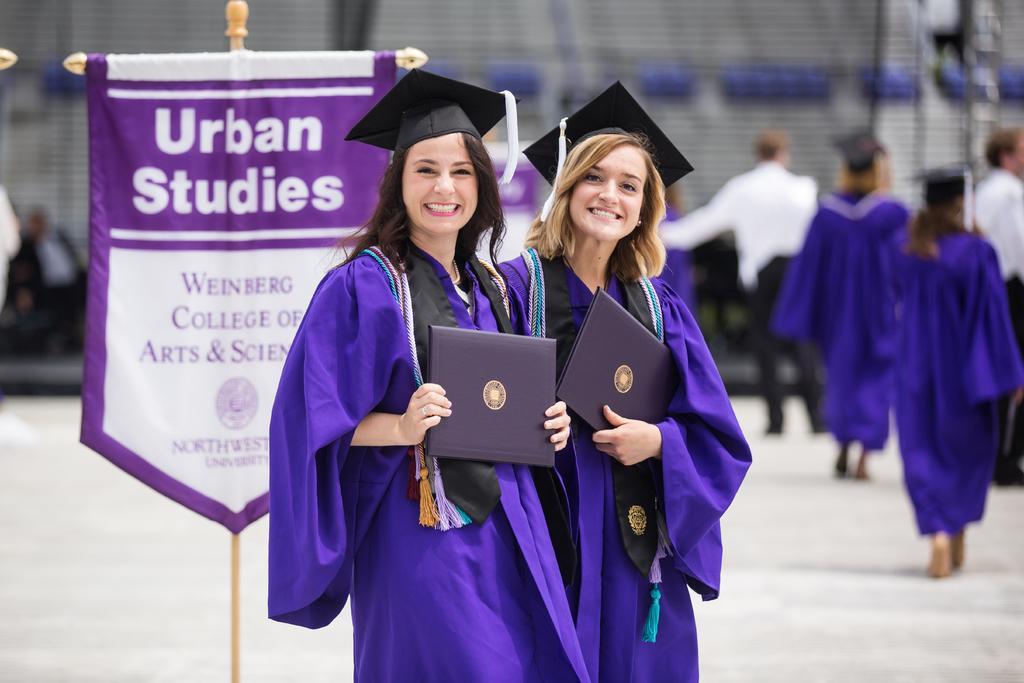In one or two sentences, can you explain what this image depicts? In the middle of the image we can see two women standing on the floor and holding certificates in their hands. In the background we can see advertisement and some persons on the ground. 